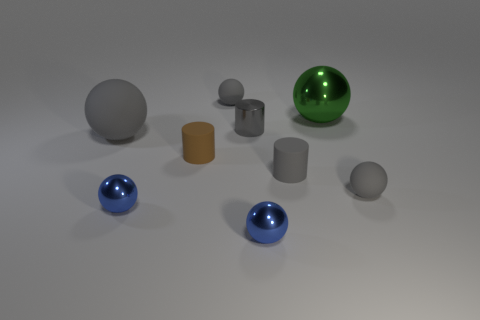Do the brown matte object and the green object to the right of the large gray rubber object have the same shape?
Your response must be concise. No. The other rubber thing that is the same shape as the brown rubber thing is what size?
Your answer should be compact. Small. There is a large matte object; does it have the same color as the matte object that is to the right of the big green shiny thing?
Provide a succinct answer. Yes. How many other things are the same size as the gray matte cylinder?
Offer a terse response. 6. What shape is the large object on the right side of the gray object on the left side of the sphere behind the large green shiny sphere?
Your response must be concise. Sphere. Does the brown cylinder have the same size as the metal ball that is behind the tiny shiny cylinder?
Your answer should be compact. No. What is the color of the thing that is both behind the tiny brown object and right of the gray metallic object?
Your answer should be compact. Green. What number of other objects are the same shape as the green thing?
Your response must be concise. 5. Do the small matte ball behind the gray metallic cylinder and the matte thing to the left of the small brown matte cylinder have the same color?
Make the answer very short. Yes. Do the brown thing to the left of the large green shiny thing and the metal ball behind the big gray object have the same size?
Keep it short and to the point. No. 